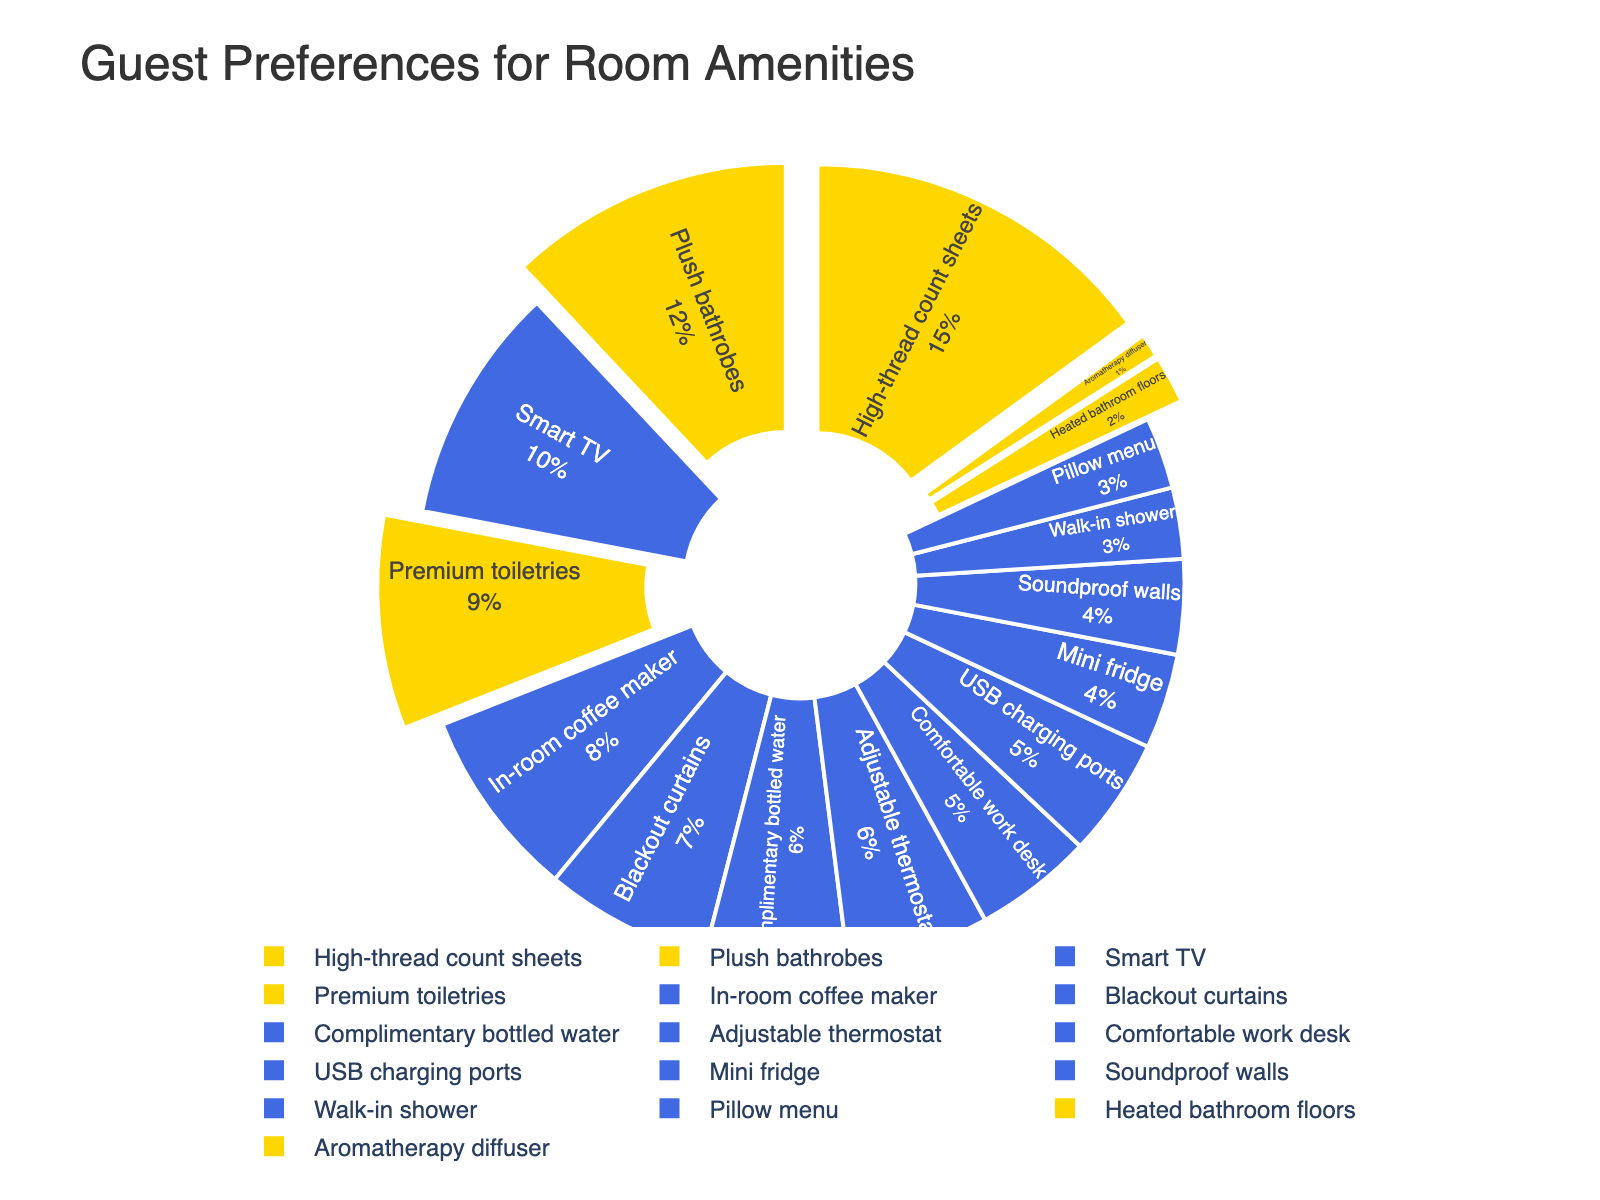What's the most preferred room amenity? The figure shows percentages of each amenity preference. The 'High-thread count sheets' segment will occupy the largest area, indicating it is the most preferred.
Answer: High-thread count sheets Which amenity is more preferred, 'Plush bathrobes' or 'Smart TV'? By comparing the sizes of both segments in the pie chart, 'Plush bathrobes' have a larger segment with 12%, while 'Smart TV' has 10%. Hence, 'Plush bathrobes' is more preferred.
Answer: Plush bathrobes What percentage of guests prefer luxury amenities over comfort amenities? First, identify amenities categorized as luxury, then sum their percentages. Luxury items are 'High-thread count sheets' (15%), 'Plush bathrobes' (12%), 'Premium toiletries' (9%), 'Heated bathroom floors' (2%), and 'Aromatherapy diffuser' (1%). Sum these percentages: 15 + 12 + 9 + 2 + 1 = 39%.
Answer: 39% Are 'USB charging ports' more preferred than 'Mini fridge'? Check their respective segments to see which is larger. 'USB charging ports' have 5%, while 'Mini fridge' has 4%; thus, 'USB charging ports' are more preferred.
Answer: Yes What's the combined preference percentage for 'Comfortable work desk' and 'Soundproof walls'? The figure indicates 'Comfortable work desk' has 5% and 'Soundproof walls' has 4%. Adding these percentages: 5 + 4 = 9%.
Answer: 9% Between 'In-room coffee maker' and 'Blackout curtains', which has a higher preference and by how much? 'In-room coffee maker' is preferred by 8% and 'Blackout curtains' by 7%. Subtracting their percentages: 8 - 7 = 1%. Therefore, 'In-room coffee maker' is preferred by 1% more than 'Blackout curtains'.
Answer: In-room coffee maker by 1% What fraction of guests prefer USB charging ports compared to those who prefer an Adjustable thermostat? Both 'USB charging ports' and 'Adjustable thermostat' have 5% and 6%, respectively. Thus, the fraction is 5/6. Simplifying, this fraction is approximately 0.83.
Answer: 5/6 Which categories of amenities (Luxury vs Comfort) have more variety? Count the number of amenities in each category. 'Luxury' items include 5 amenities (High-thread count sheets, Plush bathrobes, Premium toiletries, Heated bathroom floors, Aromatherapy diffuser), while 'Comfort' items include 11 amenities. Hence, 'Comfort' has more variety.
Answer: Comfort Is there an amenity with exactly the median preference percentage? If so, what is it? To find the median, list the percentages in order: 1, 2, 3, 3, 4, 4, 5, 5, 6, 6, 7, 8, 9, 10, 12, 15. The median is the average of the 8th and 9th values: (5 + 6) / 2 = 5.5. No exact amenity matches this median value.
Answer: No 